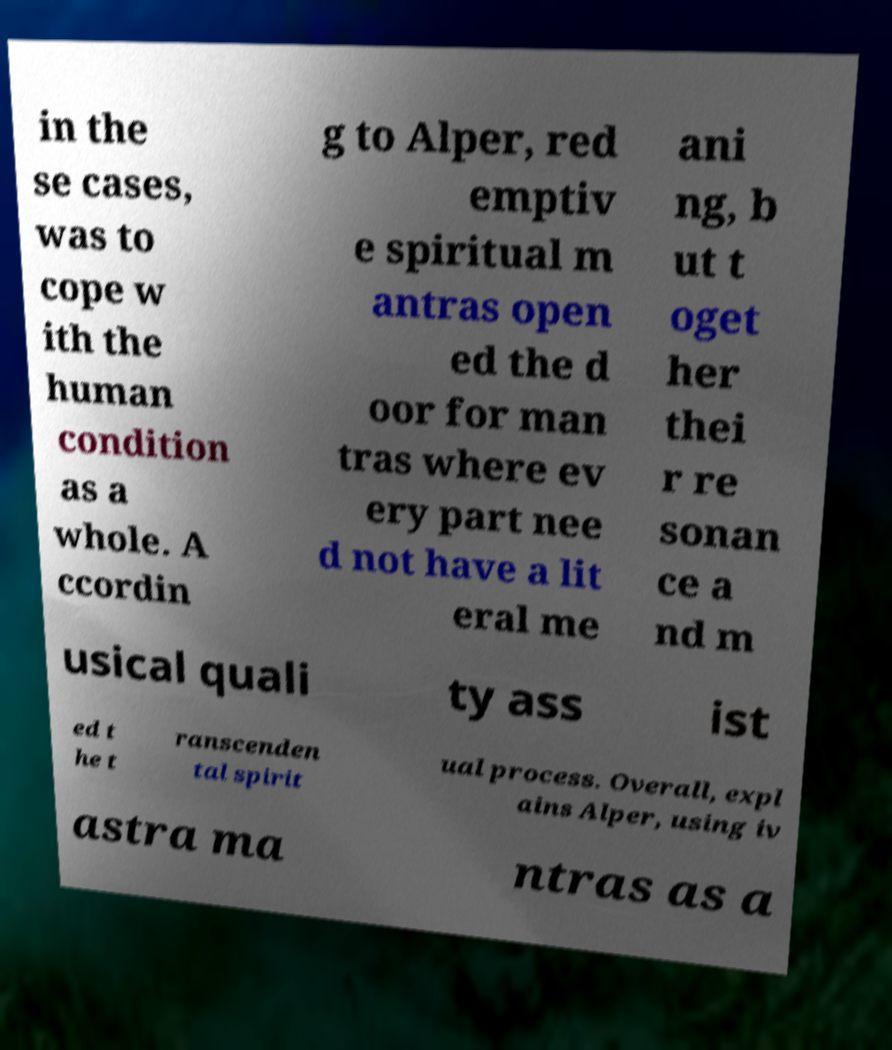Please read and relay the text visible in this image. What does it say? in the se cases, was to cope w ith the human condition as a whole. A ccordin g to Alper, red emptiv e spiritual m antras open ed the d oor for man tras where ev ery part nee d not have a lit eral me ani ng, b ut t oget her thei r re sonan ce a nd m usical quali ty ass ist ed t he t ranscenden tal spirit ual process. Overall, expl ains Alper, using iv astra ma ntras as a 